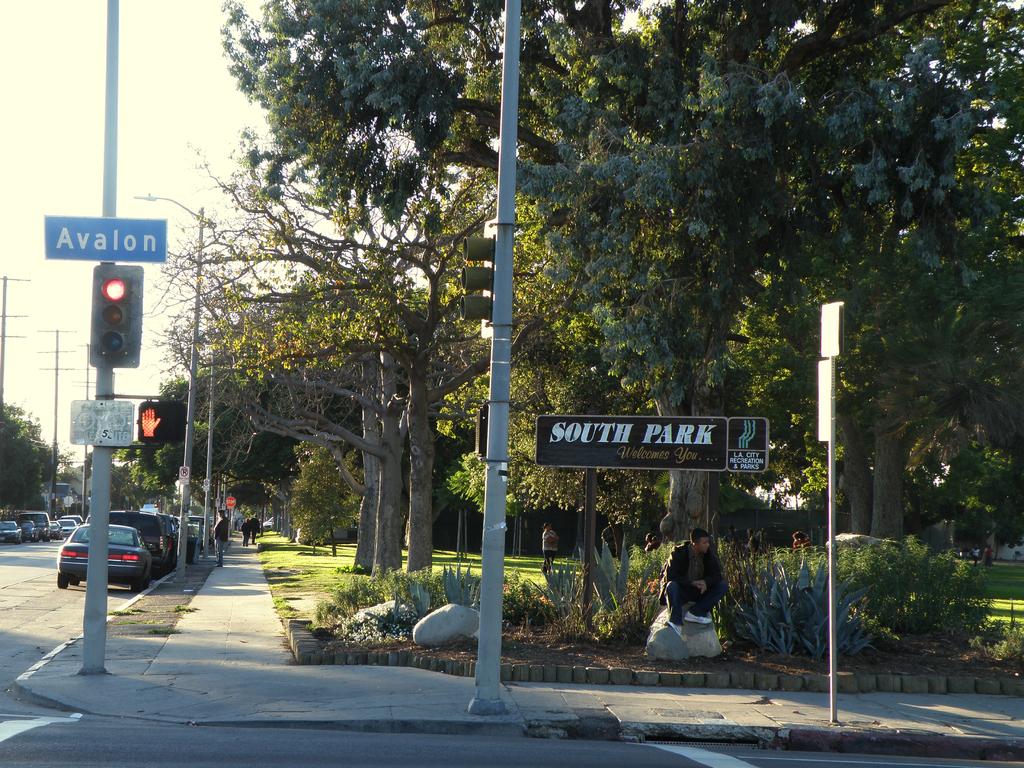What is the cross street?
Keep it short and to the point. Avalon. What does the black sing say?
Keep it short and to the point. South park. 